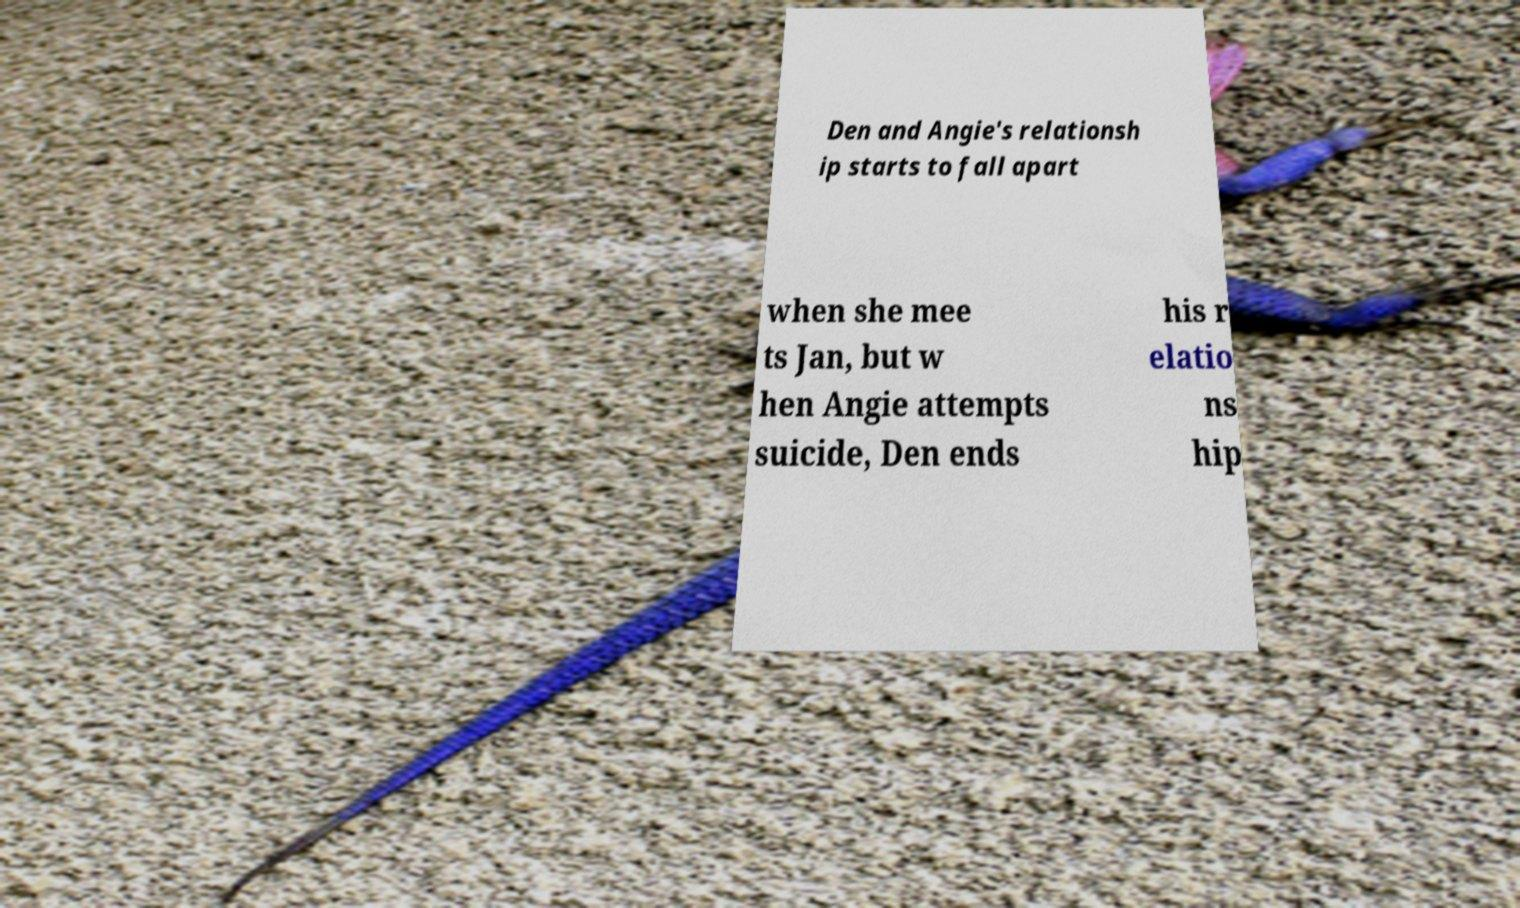Could you assist in decoding the text presented in this image and type it out clearly? Den and Angie's relationsh ip starts to fall apart when she mee ts Jan, but w hen Angie attempts suicide, Den ends his r elatio ns hip 